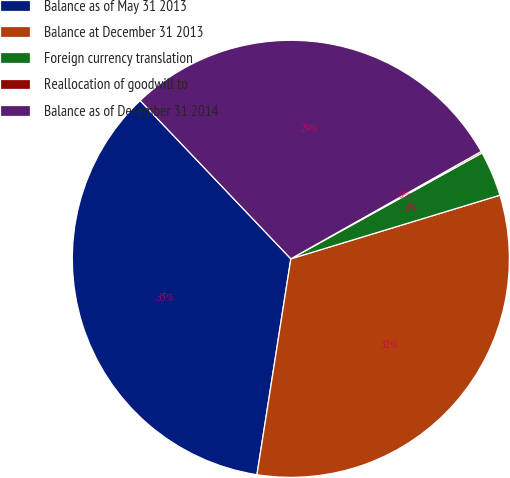Convert chart. <chart><loc_0><loc_0><loc_500><loc_500><pie_chart><fcel>Balance as of May 31 2013<fcel>Balance at December 31 2013<fcel>Foreign currency translation<fcel>Reallocation of goodwill to<fcel>Balance as of December 31 2014<nl><fcel>35.41%<fcel>32.18%<fcel>3.35%<fcel>0.12%<fcel>28.94%<nl></chart> 